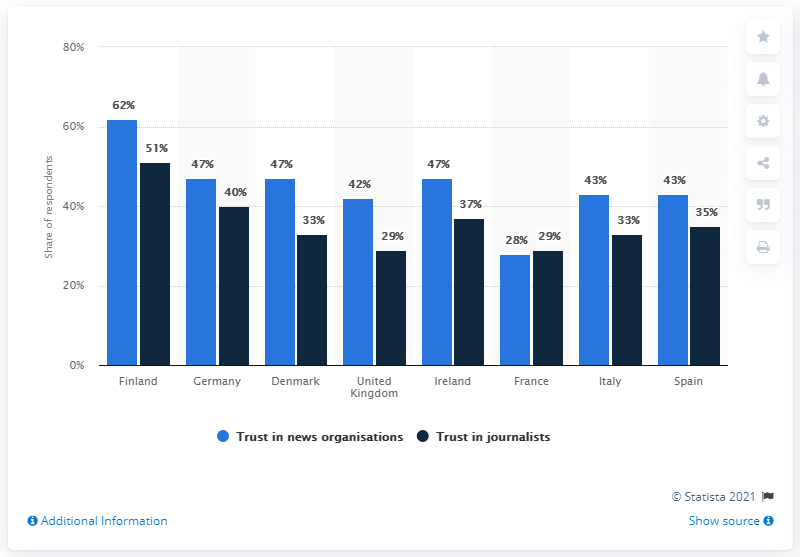How does the public trust in journalists in Finland compare with its trust in news organizations? Public trust in journalists in Finland is at 51%, which is slightly lower than the trust in news organizations, which stands at 62%. This suggests that while there is a significant confidence in the press, individuals may slightly differentiate their trust between the institutions and the journalists themselves. 